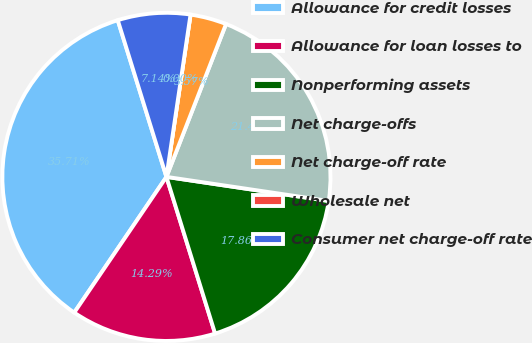Convert chart to OTSL. <chart><loc_0><loc_0><loc_500><loc_500><pie_chart><fcel>Allowance for credit losses<fcel>Allowance for loan losses to<fcel>Nonperforming assets<fcel>Net charge-offs<fcel>Net charge-off rate<fcel>Wholesale net<fcel>Consumer net charge-off rate<nl><fcel>35.71%<fcel>14.29%<fcel>17.86%<fcel>21.43%<fcel>3.57%<fcel>0.0%<fcel>7.14%<nl></chart> 